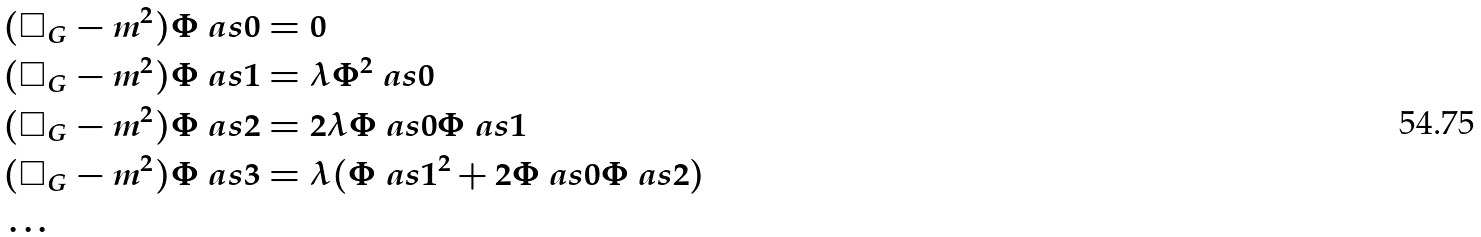Convert formula to latex. <formula><loc_0><loc_0><loc_500><loc_500>& ( \square _ { G } - m ^ { 2 } ) \Phi \ a s { 0 } = 0 \\ & ( \square _ { G } - m ^ { 2 } ) \Phi \ a s { 1 } = \lambda \Phi ^ { 2 } \ a s { 0 } \\ & ( \square _ { G } - m ^ { 2 } ) \Phi \ a s { 2 } = 2 \lambda \Phi \ a s { 0 } \Phi \ a s { 1 } \\ & ( \square _ { G } - m ^ { 2 } ) \Phi \ a s { 3 } = \lambda ( \Phi \ a s { 1 } ^ { 2 } + 2 \Phi \ a s { 0 } \Phi \ a s { 2 } ) \\ & \dots</formula> 